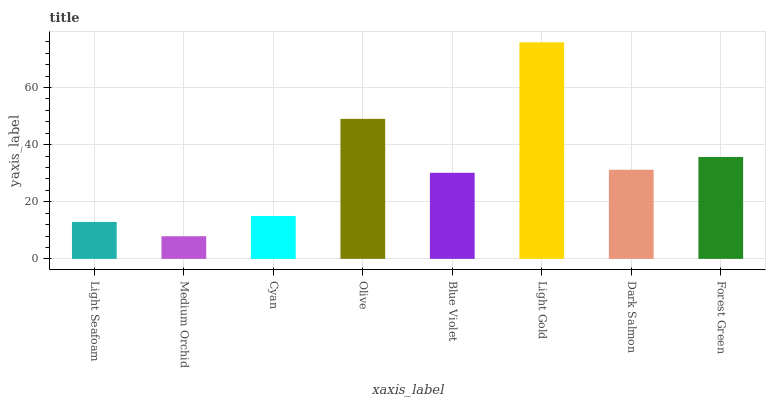Is Medium Orchid the minimum?
Answer yes or no. Yes. Is Light Gold the maximum?
Answer yes or no. Yes. Is Cyan the minimum?
Answer yes or no. No. Is Cyan the maximum?
Answer yes or no. No. Is Cyan greater than Medium Orchid?
Answer yes or no. Yes. Is Medium Orchid less than Cyan?
Answer yes or no. Yes. Is Medium Orchid greater than Cyan?
Answer yes or no. No. Is Cyan less than Medium Orchid?
Answer yes or no. No. Is Dark Salmon the high median?
Answer yes or no. Yes. Is Blue Violet the low median?
Answer yes or no. Yes. Is Light Gold the high median?
Answer yes or no. No. Is Light Seafoam the low median?
Answer yes or no. No. 